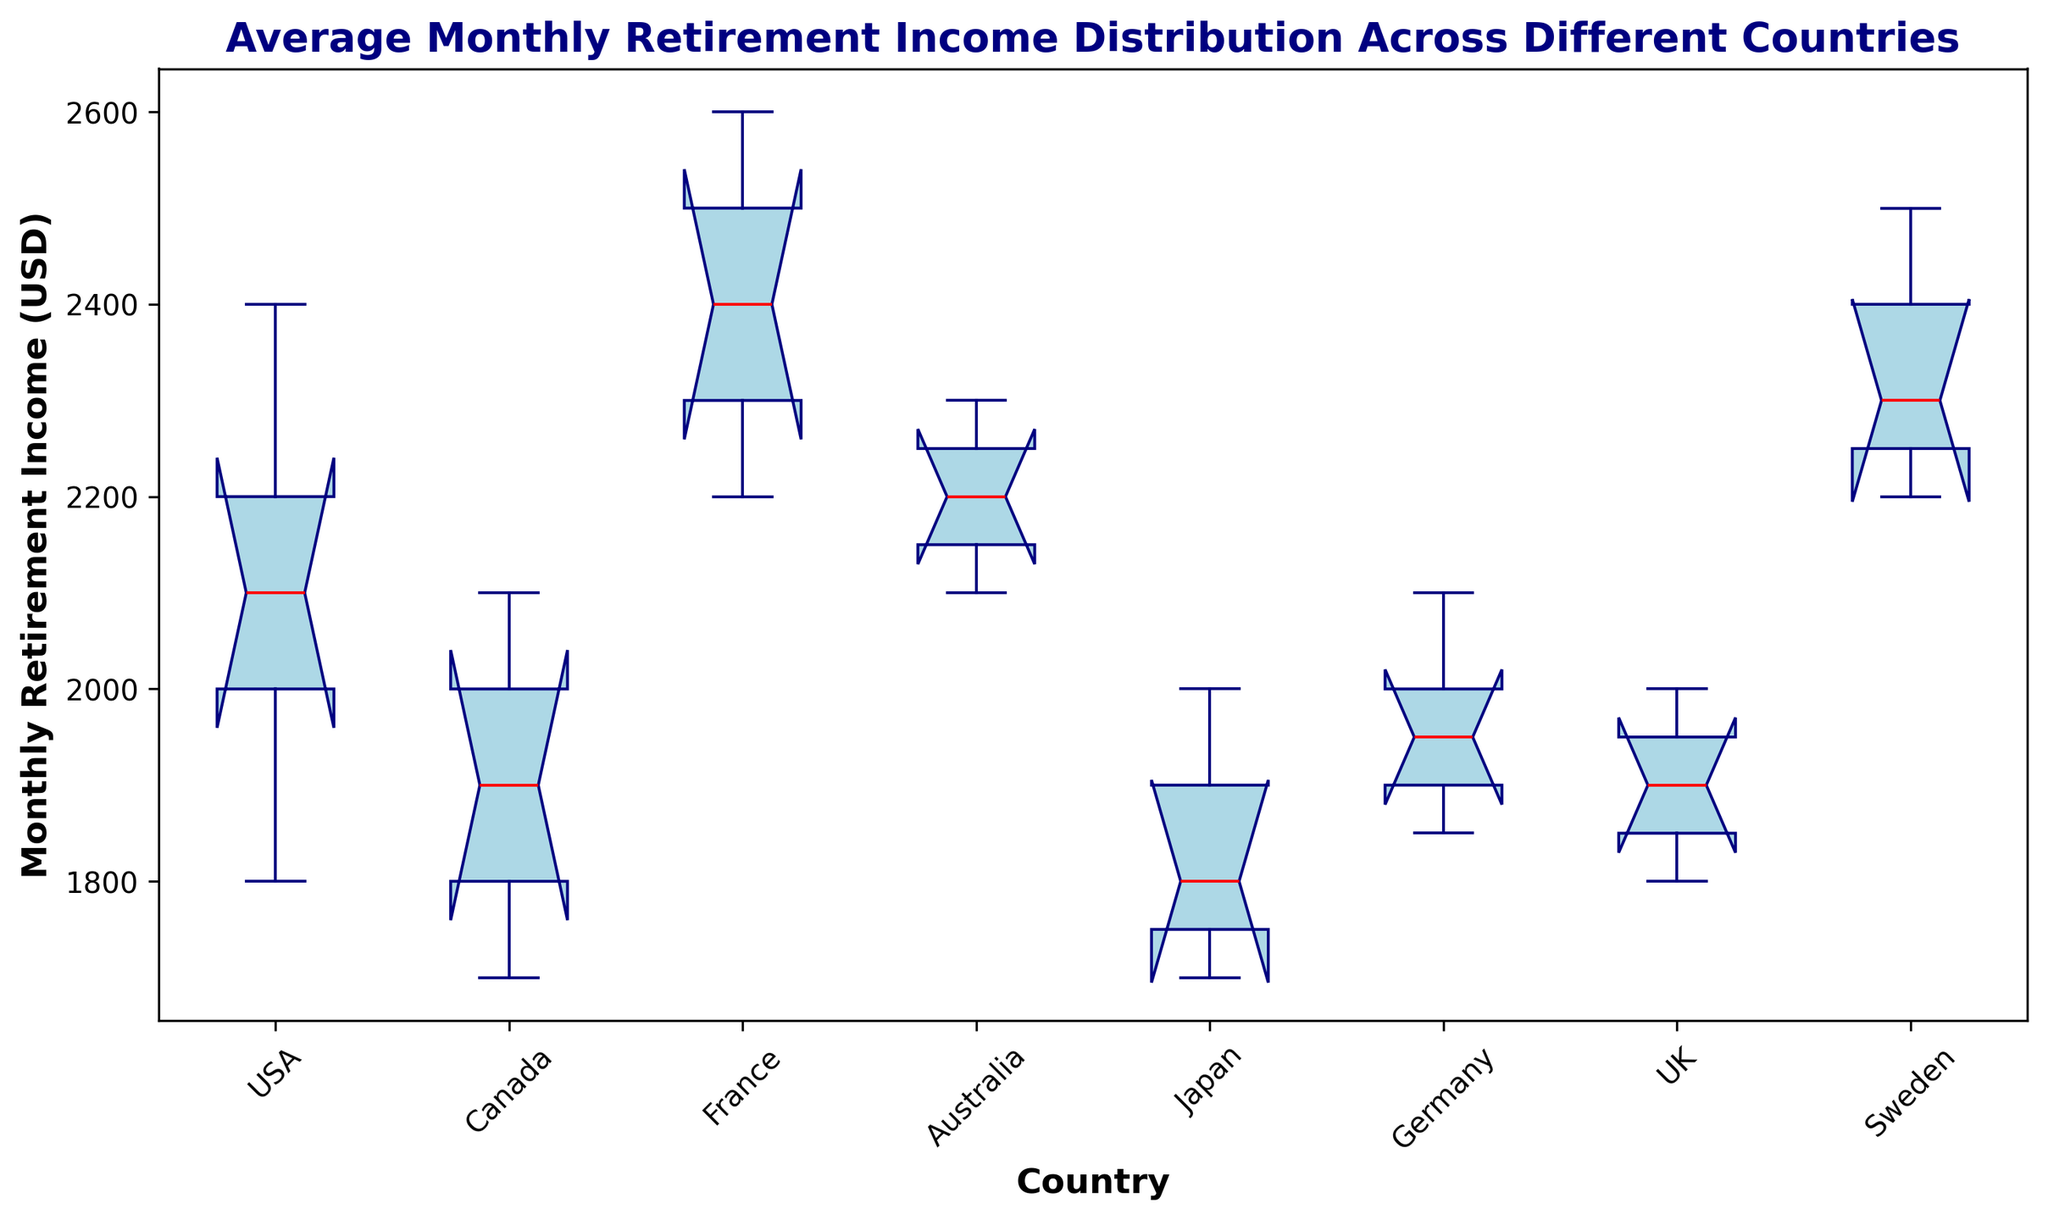What is the median monthly retirement income in the USA? The box plot shows median values with a red line in the boxes. In the box for the USA, the median value corresponds to the red line inside the box for the USA.
Answer: 2100 Which country has the highest median monthly retirement income? To determine this, I need to find the red line, representing the median, which is highest among all the boxes. The highest median value is shown in France's box plot.
Answer: France What's the range of monthly retirement income in Canada? The range is the difference between the smallest and largest data points within the whiskers. For Canada, the lowest value is 1700, and the highest is 2100, hence the range is 2100 - 1700.
Answer: 400 Which country has the widest interquartile range (IQR) for monthly retirement income? The IQR is represented by the height of the box. By comparing all boxes, the one with the largest height corresponds to the country with the widest IQR. The UK has the widest IQR.
Answer: UK Compare the median monthly retirement income of Australia and Japan. Which country has a higher median? By observing the red median lines, Australia's median is higher than Japan's.
Answer: Australia Is the median monthly retirement income higher in Germany or the UK? The red median lines show that Germany's median is higher than the UK's median.
Answer: Germany Which country's retirement income data has the most outliers? Outliers are depicted as individual points beyond the whiskers. By examining all the box plots, there are no outliers shown for any country.
Answer: None What is the maximum monthly retirement income observed in Sweden? The maximum value is the topmost point of the upper whisker in Sweden's box plot.
Answer: 2500 Which country has the narrowest overall range of monthly retirement income? The overall range is the difference between the highest and lowest points. By comparing all whiskers, the USA has the narrowest range.
Answer: USA What is the 25th percentile (Q1) monthly retirement income for France? The 25th percentile is represented by the bottom edge of the box. For France, the bottom edge of the box indicates the Q1 value.
Answer: 2300 